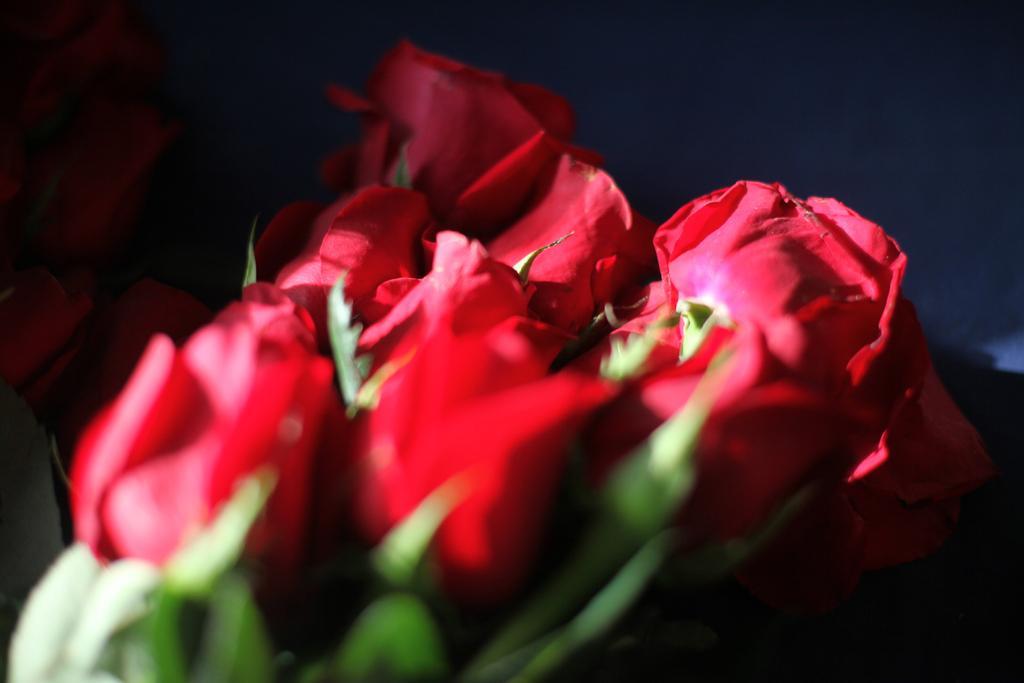Describe this image in one or two sentences. In this picture I can see there are a few red roses and there are few more in the backdrop and the backdrop is dark. The roses have stems and leaves. 